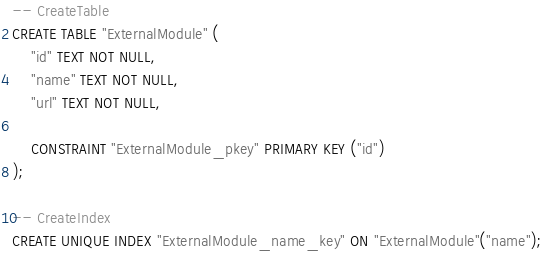<code> <loc_0><loc_0><loc_500><loc_500><_SQL_>-- CreateTable
CREATE TABLE "ExternalModule" (
    "id" TEXT NOT NULL,
    "name" TEXT NOT NULL,
    "url" TEXT NOT NULL,

    CONSTRAINT "ExternalModule_pkey" PRIMARY KEY ("id")
);

-- CreateIndex
CREATE UNIQUE INDEX "ExternalModule_name_key" ON "ExternalModule"("name");
</code> 